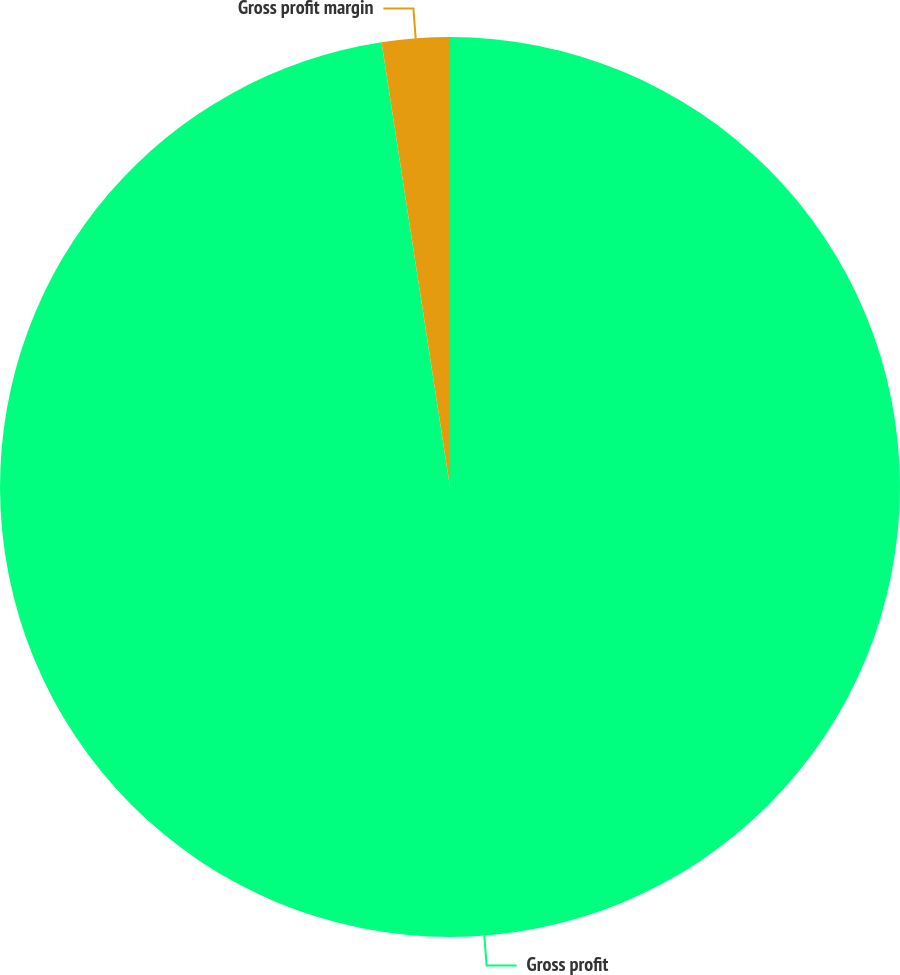Convert chart. <chart><loc_0><loc_0><loc_500><loc_500><pie_chart><fcel>Gross profit<fcel>Gross profit margin<nl><fcel>97.57%<fcel>2.43%<nl></chart> 